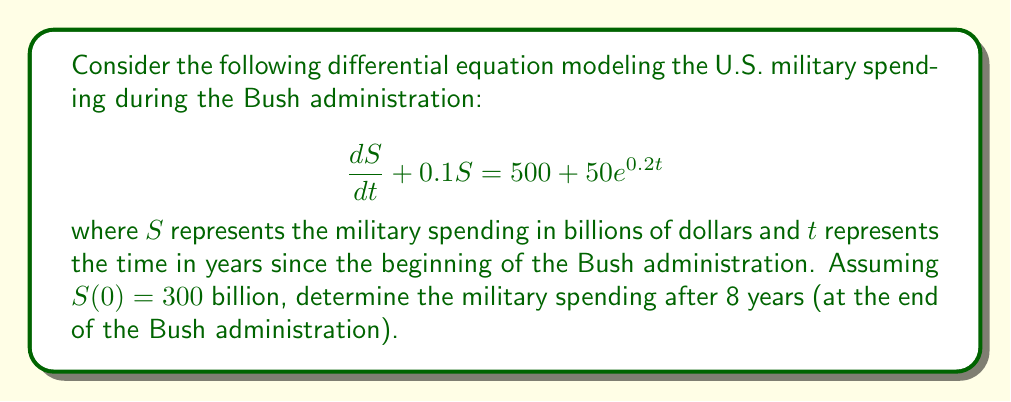Can you answer this question? To solve this problem, we'll follow these steps:

1) First, we recognize this as a first-order linear differential equation in the form:

   $$\frac{dS}{dt} + P(t)S = Q(t)$$

   where $P(t) = 0.1$ and $Q(t) = 500 + 50e^{0.2t}$

2) The integrating factor is:

   $$\mu(t) = e^{\int P(t) dt} = e^{0.1t}$$

3) Multiplying both sides of the equation by $\mu(t)$:

   $$e^{0.1t}\frac{dS}{dt} + 0.1e^{0.1t}S = 500e^{0.1t} + 50e^{0.3t}$$

4) The left side is now the derivative of $e^{0.1t}S$, so we can write:

   $$\frac{d}{dt}(e^{0.1t}S) = 500e^{0.1t} + 50e^{0.3t}$$

5) Integrating both sides:

   $$e^{0.1t}S = 5000e^{0.1t} + \frac{50}{0.2}e^{0.3t} + C$$

6) Solving for $S$:

   $$S = 5000 + 250e^{0.2t} + Ce^{-0.1t}$$

7) Using the initial condition $S(0) = 300$:

   $$300 = 5000 + 250 + C$$
   $$C = -4950$$

8) Therefore, the general solution is:

   $$S(t) = 5000 + 250e^{0.2t} - 4950e^{-0.1t}$$

9) To find the spending after 8 years, we evaluate $S(8)$:

   $$S(8) = 5000 + 250e^{1.6} - 4950e^{-0.8}$$
   $$S(8) \approx 6236.65$$ billion dollars
Answer: $6236.65$ billion dollars 